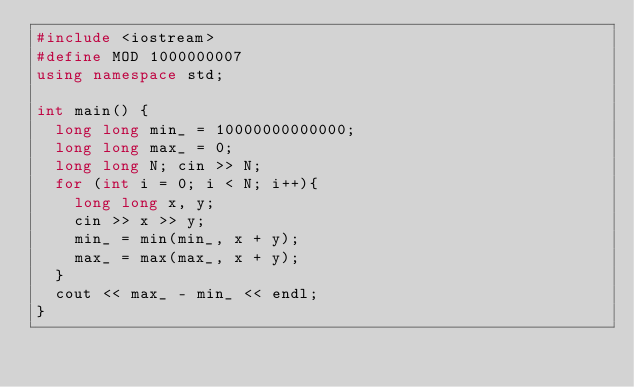<code> <loc_0><loc_0><loc_500><loc_500><_C++_>#include <iostream>
#define MOD 1000000007
using namespace std;

int main() {
  long long min_ = 10000000000000;
  long long max_ = 0;
  long long N; cin >> N;
  for (int i = 0; i < N; i++){
    long long x, y;
    cin >> x >> y;
    min_ = min(min_, x + y);
    max_ = max(max_, x + y);
  }
  cout << max_ - min_ << endl;
}</code> 